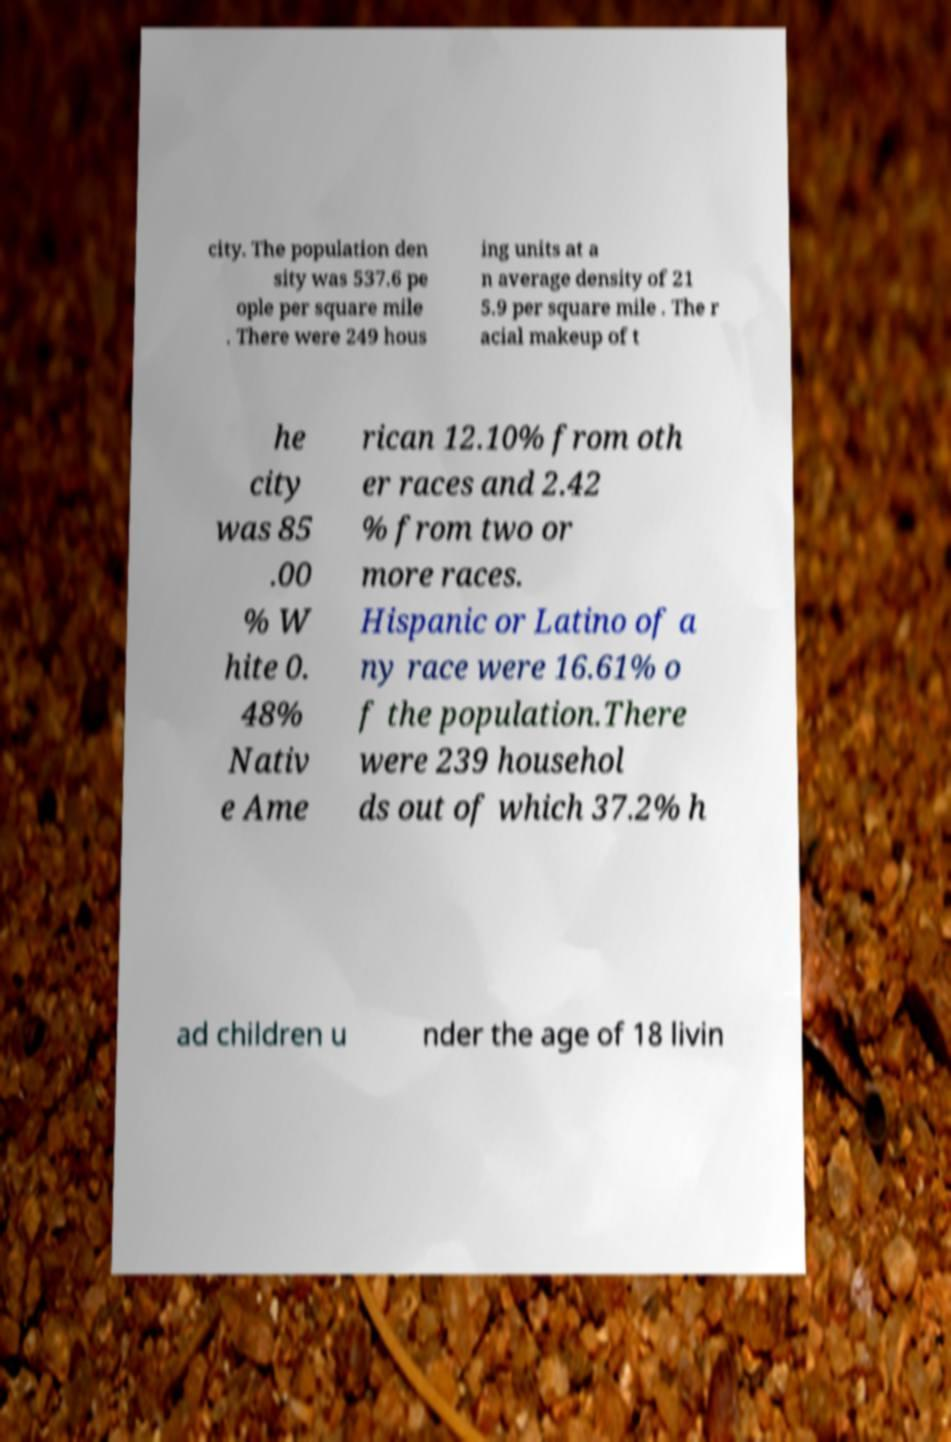What messages or text are displayed in this image? I need them in a readable, typed format. city. The population den sity was 537.6 pe ople per square mile . There were 249 hous ing units at a n average density of 21 5.9 per square mile . The r acial makeup of t he city was 85 .00 % W hite 0. 48% Nativ e Ame rican 12.10% from oth er races and 2.42 % from two or more races. Hispanic or Latino of a ny race were 16.61% o f the population.There were 239 househol ds out of which 37.2% h ad children u nder the age of 18 livin 